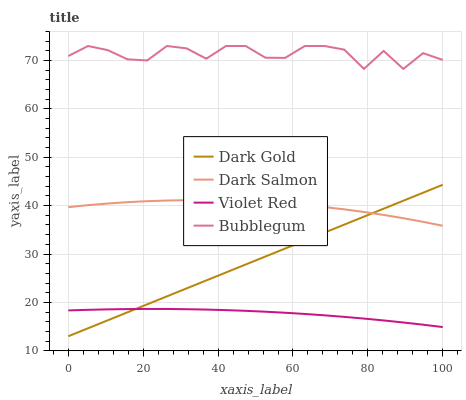Does Violet Red have the minimum area under the curve?
Answer yes or no. Yes. Does Bubblegum have the maximum area under the curve?
Answer yes or no. Yes. Does Dark Salmon have the minimum area under the curve?
Answer yes or no. No. Does Dark Salmon have the maximum area under the curve?
Answer yes or no. No. Is Dark Gold the smoothest?
Answer yes or no. Yes. Is Bubblegum the roughest?
Answer yes or no. Yes. Is Dark Salmon the smoothest?
Answer yes or no. No. Is Dark Salmon the roughest?
Answer yes or no. No. Does Dark Gold have the lowest value?
Answer yes or no. Yes. Does Dark Salmon have the lowest value?
Answer yes or no. No. Does Bubblegum have the highest value?
Answer yes or no. Yes. Does Dark Salmon have the highest value?
Answer yes or no. No. Is Dark Salmon less than Bubblegum?
Answer yes or no. Yes. Is Bubblegum greater than Violet Red?
Answer yes or no. Yes. Does Dark Gold intersect Dark Salmon?
Answer yes or no. Yes. Is Dark Gold less than Dark Salmon?
Answer yes or no. No. Is Dark Gold greater than Dark Salmon?
Answer yes or no. No. Does Dark Salmon intersect Bubblegum?
Answer yes or no. No. 